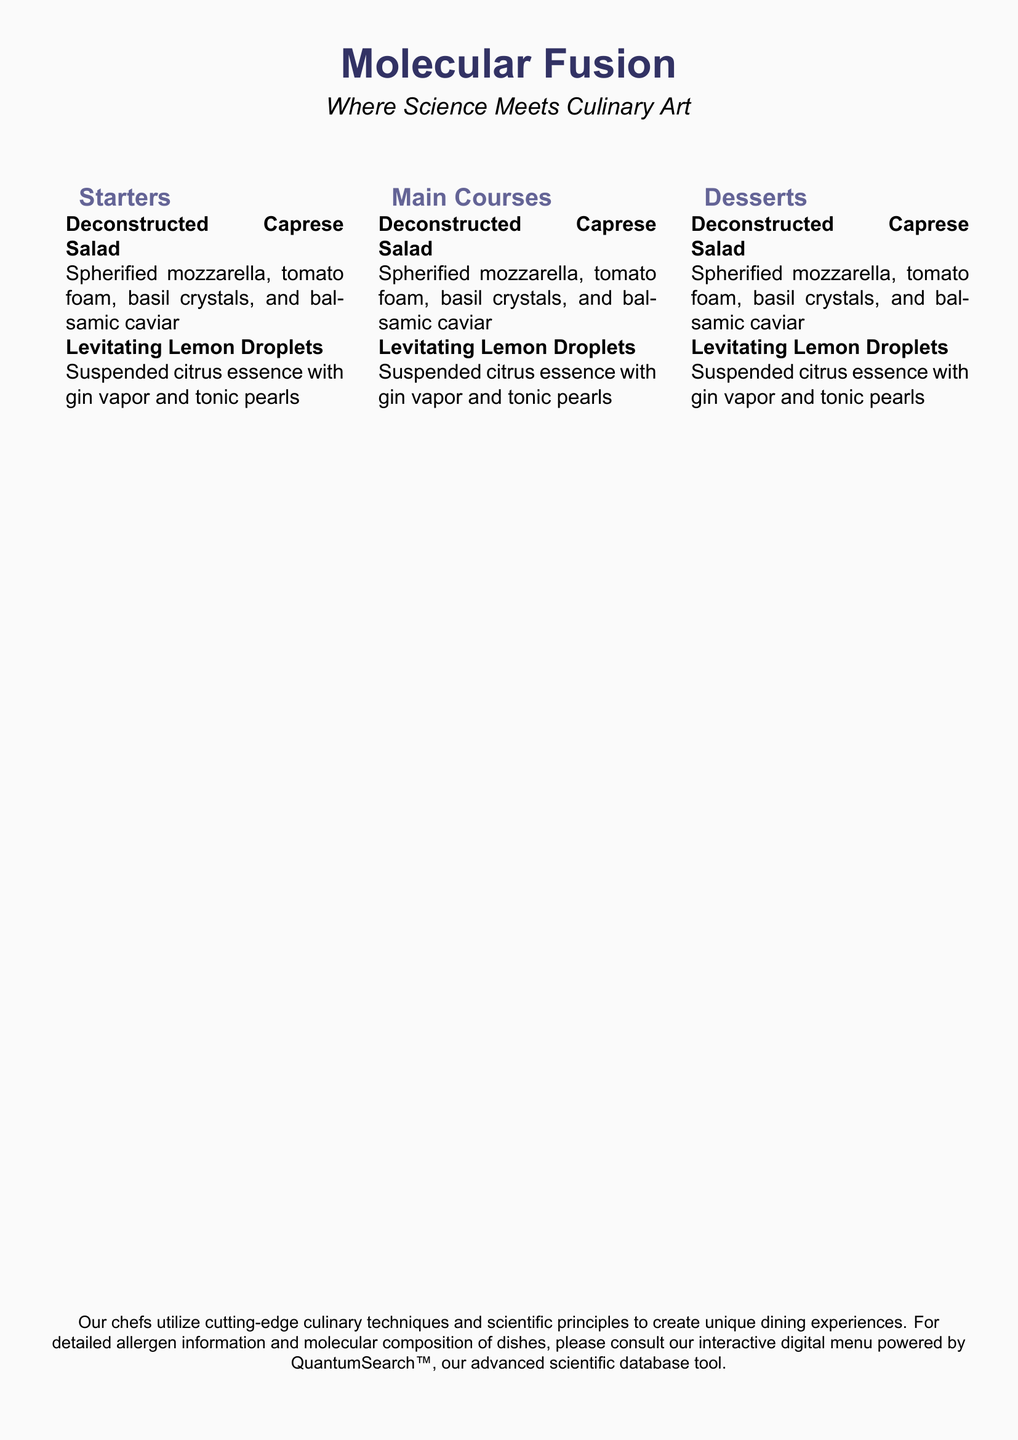what is the name of the restaurant? The name of the restaurant is prominently displayed at the top of the menu, indicating the fusion of molecular gastronomy and culinary art.
Answer: Molecular Fusion what are the signature techniques used? The menu emphasizes the use of cutting-edge culinary techniques and scientific principles in creating dishes, highlighting the concept of molecular gastronomy.
Answer: molecular gastronomy how many sections are in the menu? The menu is organized into three distinct sections, providing a clear structure for diners to choose from.
Answer: 3 what is a unique ingredient in the Deconstructed Caprese Salad? The Deconstructed Caprese Salad features several unique items that are part of molecular gastronomy, including spherified mozzarella and basil crystals.
Answer: spherified mozzarella what is an ingredient in Levitating Lemon Droplets? The Levitating Lemon Droplets include a distinctive element that enhances the dish's molecular fusion theme, such as suspended citrus essence.
Answer: suspended citrus essence which digital tool is mentioned for allergen information? The menu recommends a specific digital tool for patrons seeking details about allergens and dish compositions, which reflects its advanced technological aspect.
Answer: QuantumSearch™ what is the font used in the document? The main font used in the document is noted in the code, set to provide a clean and modern aesthetic for the menu's text presentation.
Answer: Arial what kind of experience does the restaurant aim to provide? The restaurant's description incorporates specific terminology to convey the type of dining experience they offer, focusing on the blend of science and culinary art.
Answer: unique dining experiences which dish features balsamic caviar? Within the Starters section, one of the featured dishes includes a modern twist on a classic salad that incorporates this specific molecular ingredient.
Answer: Deconstructed Caprese Salad 